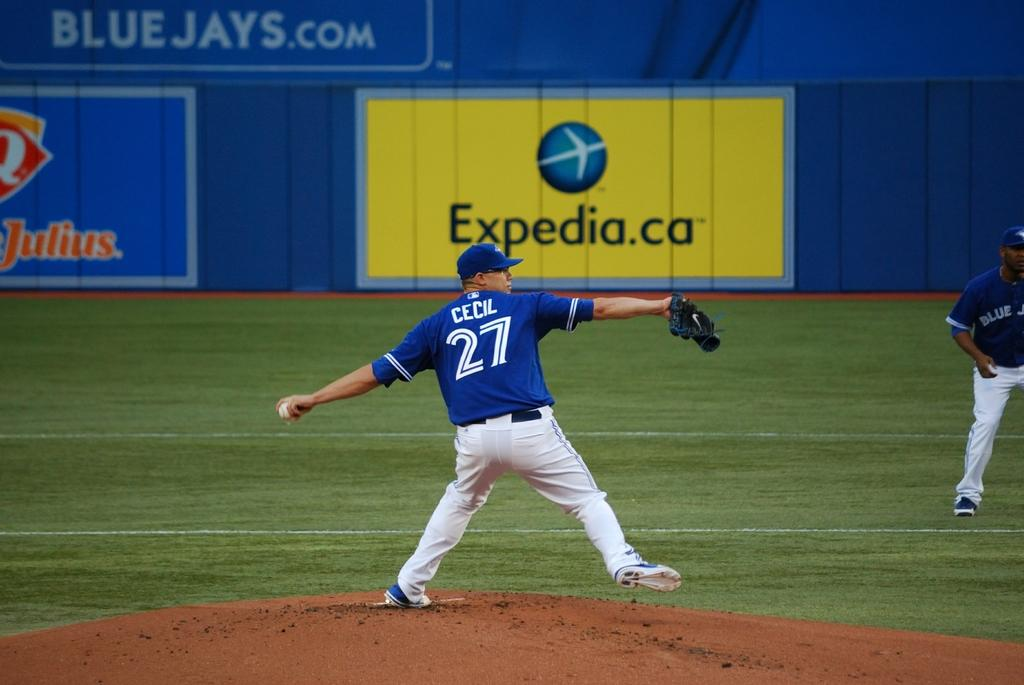<image>
Give a short and clear explanation of the subsequent image. A man pitching a baseball with an Expedia ad behind him 